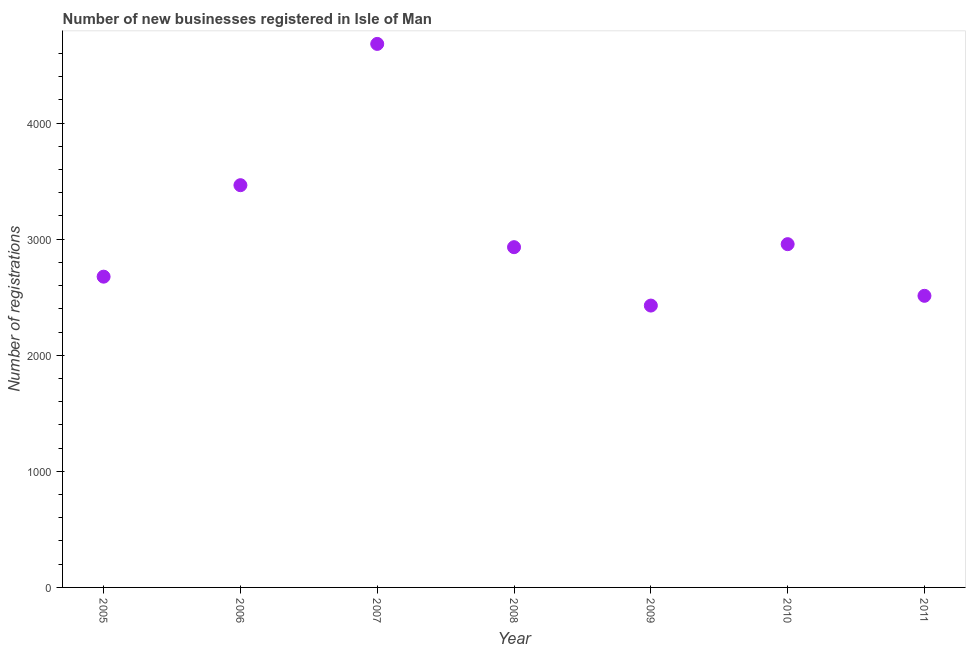What is the number of new business registrations in 2007?
Make the answer very short. 4682. Across all years, what is the maximum number of new business registrations?
Provide a short and direct response. 4682. Across all years, what is the minimum number of new business registrations?
Make the answer very short. 2428. In which year was the number of new business registrations maximum?
Offer a terse response. 2007. In which year was the number of new business registrations minimum?
Give a very brief answer. 2009. What is the sum of the number of new business registrations?
Make the answer very short. 2.17e+04. What is the difference between the number of new business registrations in 2005 and 2006?
Your answer should be compact. -788. What is the average number of new business registrations per year?
Offer a terse response. 3093.14. What is the median number of new business registrations?
Offer a very short reply. 2931. In how many years, is the number of new business registrations greater than 2000 ?
Provide a short and direct response. 7. What is the ratio of the number of new business registrations in 2006 to that in 2010?
Your response must be concise. 1.17. What is the difference between the highest and the second highest number of new business registrations?
Ensure brevity in your answer.  1217. Is the sum of the number of new business registrations in 2009 and 2010 greater than the maximum number of new business registrations across all years?
Provide a short and direct response. Yes. What is the difference between the highest and the lowest number of new business registrations?
Offer a terse response. 2254. In how many years, is the number of new business registrations greater than the average number of new business registrations taken over all years?
Offer a terse response. 2. Does the number of new business registrations monotonically increase over the years?
Give a very brief answer. No. How many dotlines are there?
Keep it short and to the point. 1. What is the difference between two consecutive major ticks on the Y-axis?
Offer a terse response. 1000. Are the values on the major ticks of Y-axis written in scientific E-notation?
Offer a terse response. No. Does the graph contain grids?
Your answer should be compact. No. What is the title of the graph?
Provide a succinct answer. Number of new businesses registered in Isle of Man. What is the label or title of the X-axis?
Give a very brief answer. Year. What is the label or title of the Y-axis?
Provide a short and direct response. Number of registrations. What is the Number of registrations in 2005?
Offer a very short reply. 2677. What is the Number of registrations in 2006?
Ensure brevity in your answer.  3465. What is the Number of registrations in 2007?
Provide a succinct answer. 4682. What is the Number of registrations in 2008?
Ensure brevity in your answer.  2931. What is the Number of registrations in 2009?
Your response must be concise. 2428. What is the Number of registrations in 2010?
Your answer should be very brief. 2957. What is the Number of registrations in 2011?
Provide a short and direct response. 2512. What is the difference between the Number of registrations in 2005 and 2006?
Provide a succinct answer. -788. What is the difference between the Number of registrations in 2005 and 2007?
Make the answer very short. -2005. What is the difference between the Number of registrations in 2005 and 2008?
Offer a terse response. -254. What is the difference between the Number of registrations in 2005 and 2009?
Offer a very short reply. 249. What is the difference between the Number of registrations in 2005 and 2010?
Provide a short and direct response. -280. What is the difference between the Number of registrations in 2005 and 2011?
Your answer should be very brief. 165. What is the difference between the Number of registrations in 2006 and 2007?
Make the answer very short. -1217. What is the difference between the Number of registrations in 2006 and 2008?
Your answer should be very brief. 534. What is the difference between the Number of registrations in 2006 and 2009?
Keep it short and to the point. 1037. What is the difference between the Number of registrations in 2006 and 2010?
Provide a short and direct response. 508. What is the difference between the Number of registrations in 2006 and 2011?
Offer a very short reply. 953. What is the difference between the Number of registrations in 2007 and 2008?
Offer a terse response. 1751. What is the difference between the Number of registrations in 2007 and 2009?
Provide a succinct answer. 2254. What is the difference between the Number of registrations in 2007 and 2010?
Provide a short and direct response. 1725. What is the difference between the Number of registrations in 2007 and 2011?
Provide a succinct answer. 2170. What is the difference between the Number of registrations in 2008 and 2009?
Ensure brevity in your answer.  503. What is the difference between the Number of registrations in 2008 and 2011?
Keep it short and to the point. 419. What is the difference between the Number of registrations in 2009 and 2010?
Offer a terse response. -529. What is the difference between the Number of registrations in 2009 and 2011?
Give a very brief answer. -84. What is the difference between the Number of registrations in 2010 and 2011?
Provide a succinct answer. 445. What is the ratio of the Number of registrations in 2005 to that in 2006?
Provide a short and direct response. 0.77. What is the ratio of the Number of registrations in 2005 to that in 2007?
Your response must be concise. 0.57. What is the ratio of the Number of registrations in 2005 to that in 2008?
Offer a very short reply. 0.91. What is the ratio of the Number of registrations in 2005 to that in 2009?
Ensure brevity in your answer.  1.1. What is the ratio of the Number of registrations in 2005 to that in 2010?
Your answer should be compact. 0.91. What is the ratio of the Number of registrations in 2005 to that in 2011?
Provide a succinct answer. 1.07. What is the ratio of the Number of registrations in 2006 to that in 2007?
Ensure brevity in your answer.  0.74. What is the ratio of the Number of registrations in 2006 to that in 2008?
Provide a short and direct response. 1.18. What is the ratio of the Number of registrations in 2006 to that in 2009?
Ensure brevity in your answer.  1.43. What is the ratio of the Number of registrations in 2006 to that in 2010?
Make the answer very short. 1.17. What is the ratio of the Number of registrations in 2006 to that in 2011?
Provide a short and direct response. 1.38. What is the ratio of the Number of registrations in 2007 to that in 2008?
Give a very brief answer. 1.6. What is the ratio of the Number of registrations in 2007 to that in 2009?
Ensure brevity in your answer.  1.93. What is the ratio of the Number of registrations in 2007 to that in 2010?
Offer a terse response. 1.58. What is the ratio of the Number of registrations in 2007 to that in 2011?
Keep it short and to the point. 1.86. What is the ratio of the Number of registrations in 2008 to that in 2009?
Your response must be concise. 1.21. What is the ratio of the Number of registrations in 2008 to that in 2011?
Provide a short and direct response. 1.17. What is the ratio of the Number of registrations in 2009 to that in 2010?
Provide a succinct answer. 0.82. What is the ratio of the Number of registrations in 2009 to that in 2011?
Ensure brevity in your answer.  0.97. What is the ratio of the Number of registrations in 2010 to that in 2011?
Provide a succinct answer. 1.18. 